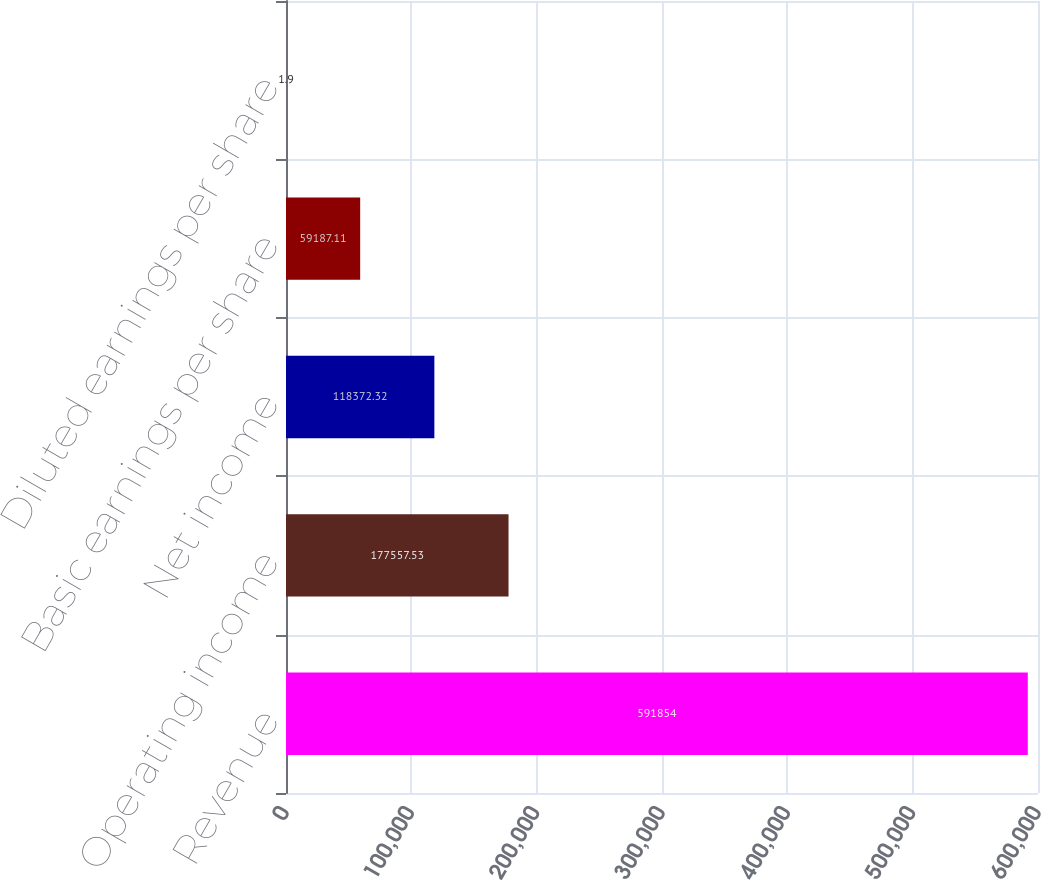<chart> <loc_0><loc_0><loc_500><loc_500><bar_chart><fcel>Revenue<fcel>Operating income<fcel>Net income<fcel>Basic earnings per share<fcel>Diluted earnings per share<nl><fcel>591854<fcel>177558<fcel>118372<fcel>59187.1<fcel>1.9<nl></chart> 